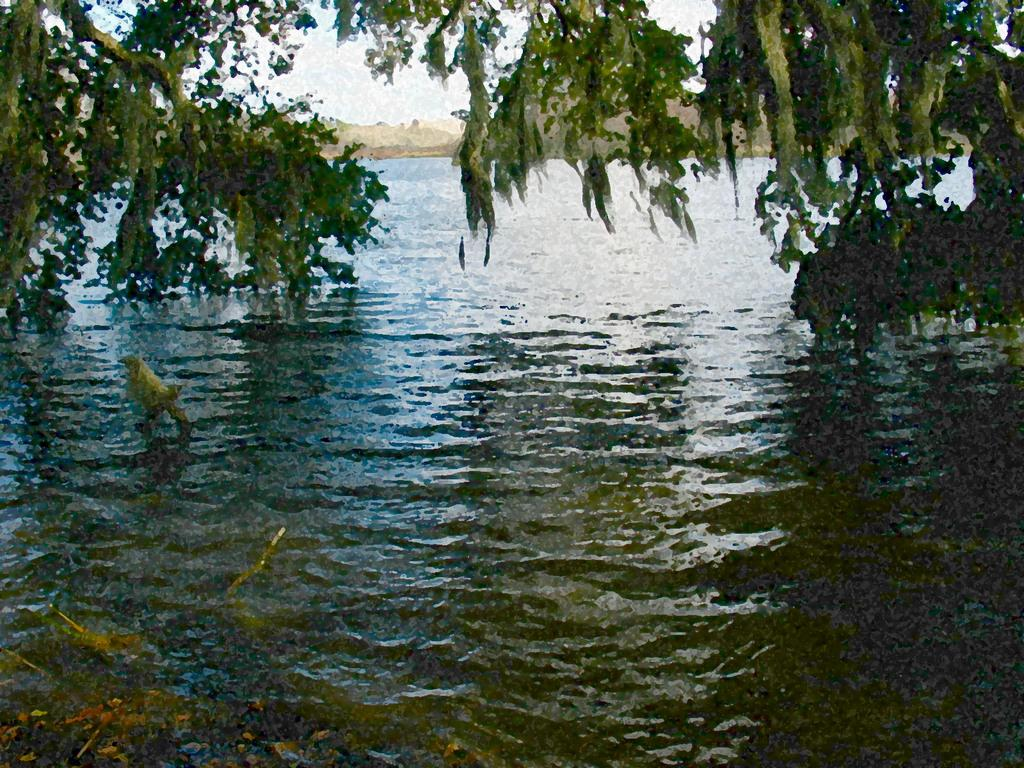What type of animal is in the image? There is a bird in the image. Where is the bird located? The bird is on the water. What can be seen in the background of the image? There are trees in the background of the image. How many flowers can be seen in the image? There are no flowers present in the image. What type of birds can be seen in the image besides the one mentioned? There is only one bird mentioned in the image, so there are no other birds to compare or contrast. 